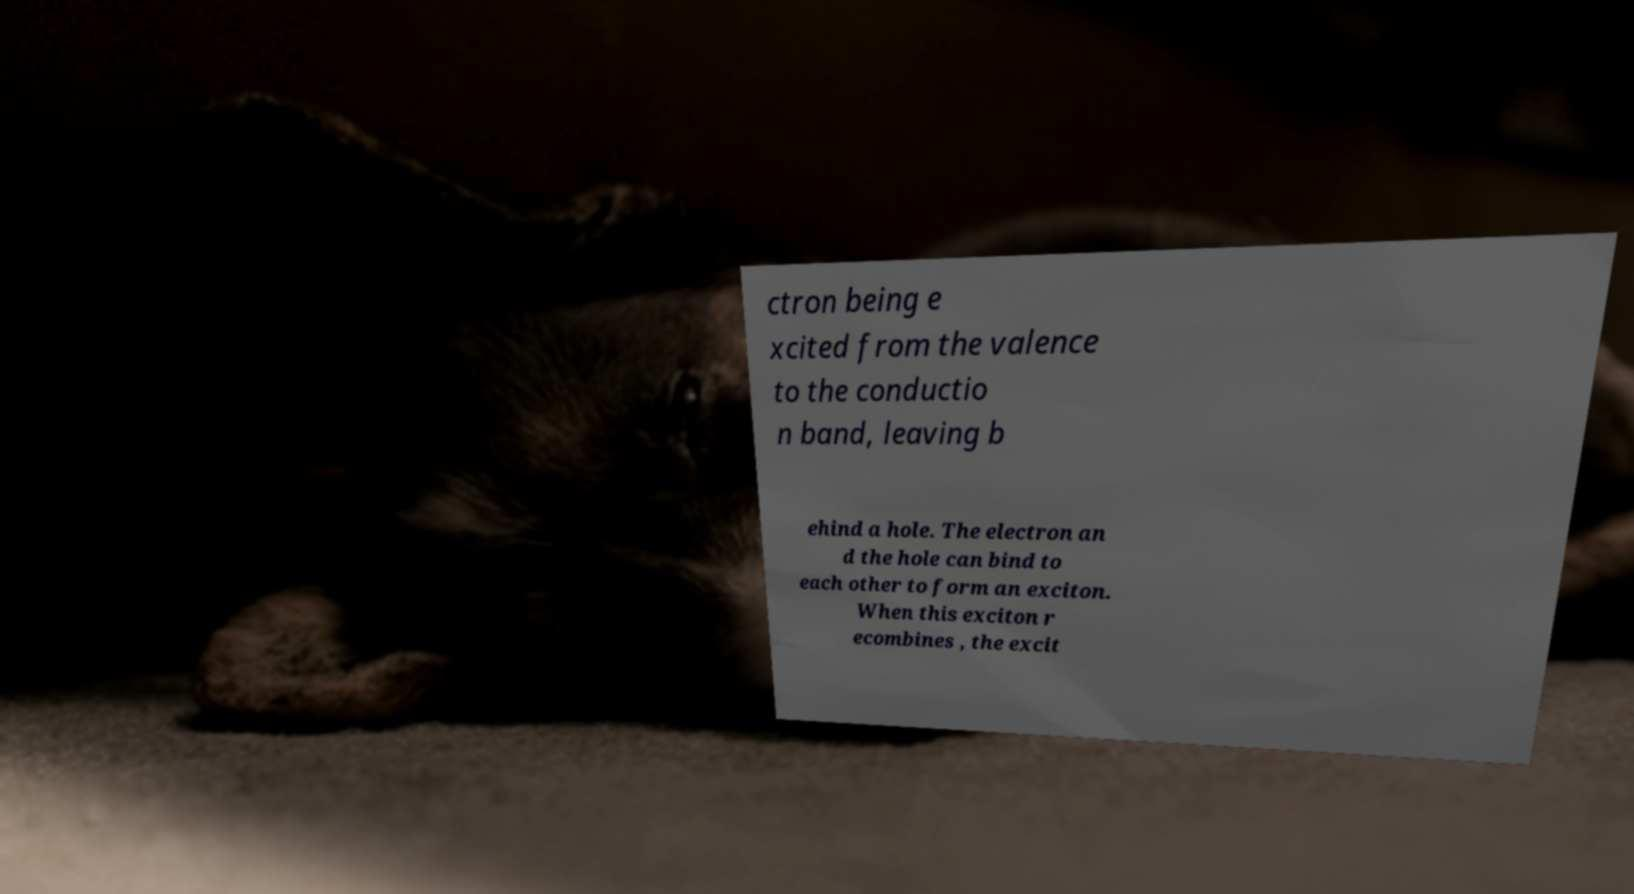Can you read and provide the text displayed in the image?This photo seems to have some interesting text. Can you extract and type it out for me? ctron being e xcited from the valence to the conductio n band, leaving b ehind a hole. The electron an d the hole can bind to each other to form an exciton. When this exciton r ecombines , the excit 